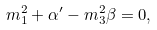Convert formula to latex. <formula><loc_0><loc_0><loc_500><loc_500>m _ { 1 } ^ { 2 } + \alpha ^ { \prime } - m _ { 3 } ^ { 2 } \beta = 0 ,</formula> 